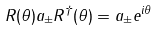<formula> <loc_0><loc_0><loc_500><loc_500>R ( \theta ) a _ { \pm } R ^ { \dag } ( \theta ) = a _ { \pm } e ^ { i \theta } \,</formula> 